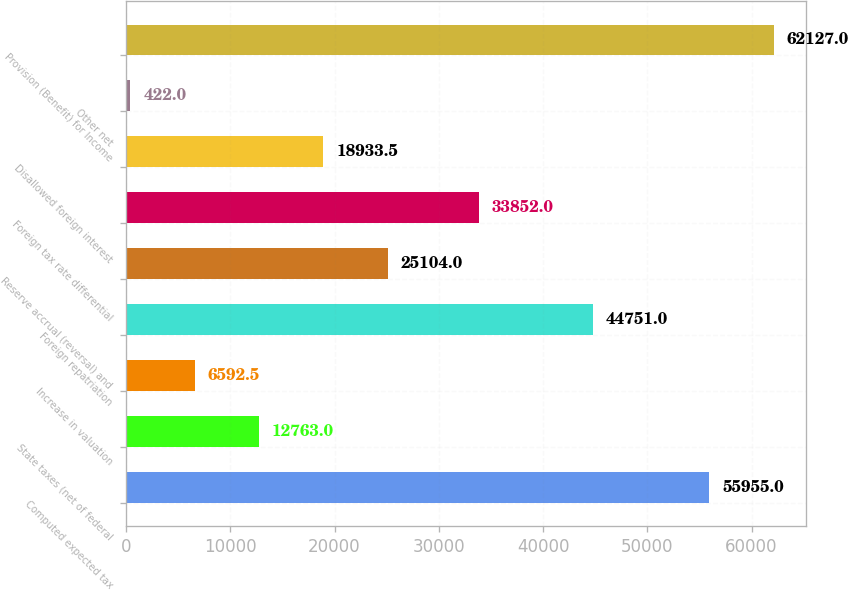<chart> <loc_0><loc_0><loc_500><loc_500><bar_chart><fcel>Computed expected tax<fcel>State taxes (net of federal<fcel>Increase in valuation<fcel>Foreign repatriation<fcel>Reserve accrual (reversal) and<fcel>Foreign tax rate differential<fcel>Disallowed foreign interest<fcel>Other net<fcel>Provision (Benefit) for Income<nl><fcel>55955<fcel>12763<fcel>6592.5<fcel>44751<fcel>25104<fcel>33852<fcel>18933.5<fcel>422<fcel>62127<nl></chart> 